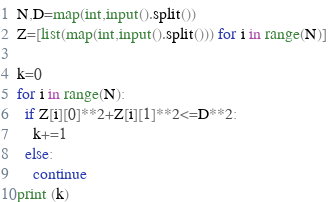Convert code to text. <code><loc_0><loc_0><loc_500><loc_500><_Python_>N,D=map(int,input().split())
Z=[list(map(int,input().split())) for i in range(N)]

k=0
for i in range(N):
  if Z[i][0]**2+Z[i][1]**2<=D**2:
    k+=1
  else:
    continue
print (k)</code> 